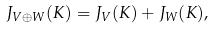<formula> <loc_0><loc_0><loc_500><loc_500>J _ { V \oplus W } ( K ) = J _ { V } ( K ) + J _ { W } ( K ) ,</formula> 